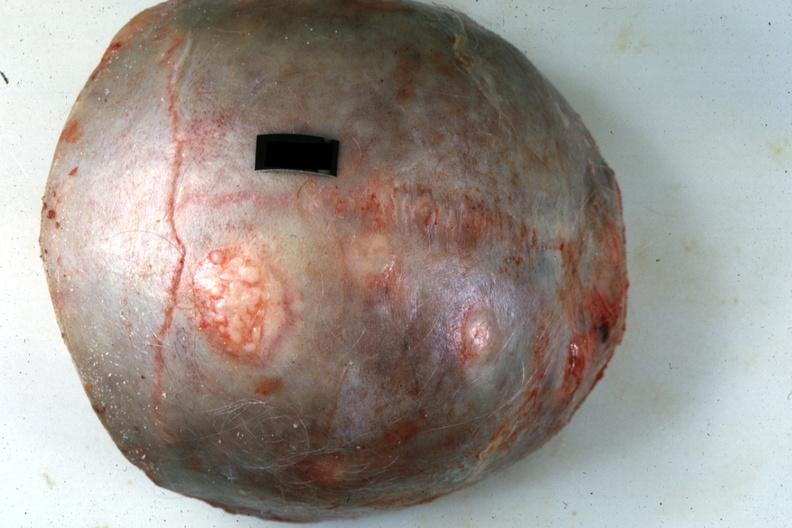what does this image show?
Answer the question using a single word or phrase. Skull cap with obvious metastatic lesions primary in pancreas 